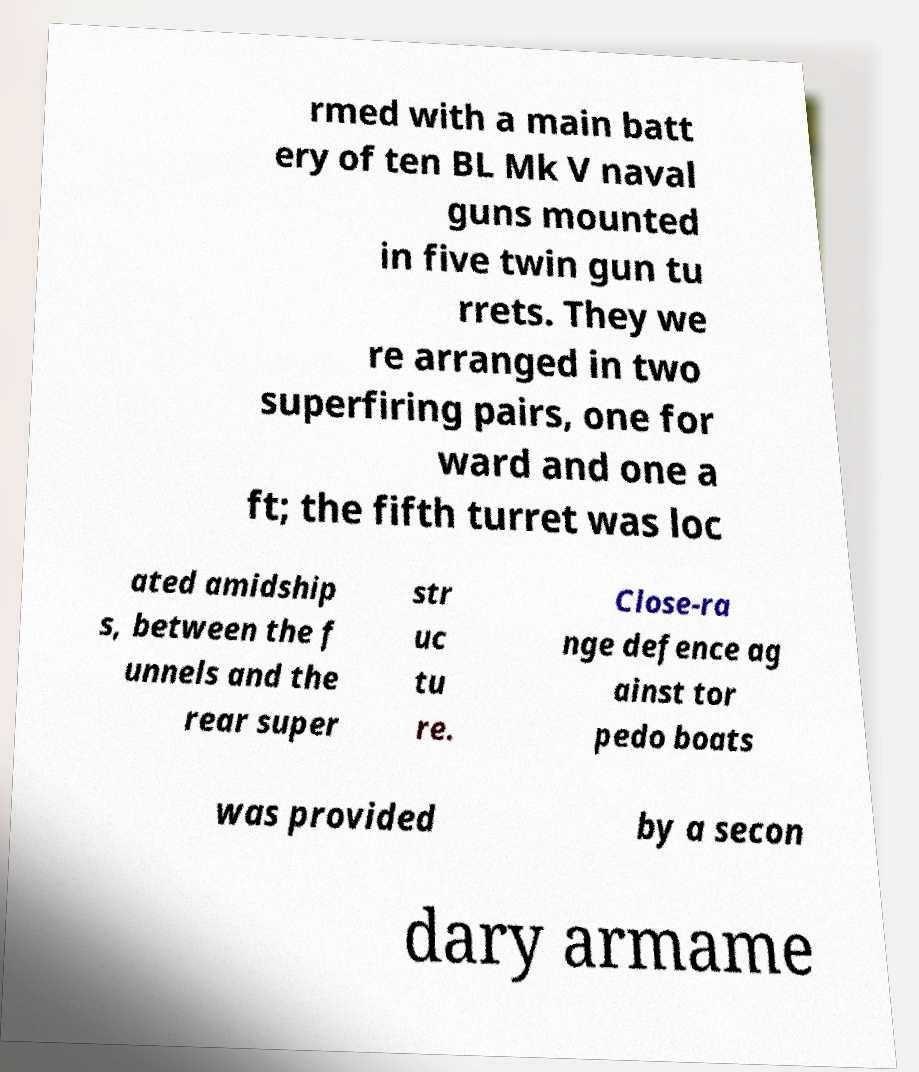Please read and relay the text visible in this image. What does it say? rmed with a main batt ery of ten BL Mk V naval guns mounted in five twin gun tu rrets. They we re arranged in two superfiring pairs, one for ward and one a ft; the fifth turret was loc ated amidship s, between the f unnels and the rear super str uc tu re. Close-ra nge defence ag ainst tor pedo boats was provided by a secon dary armame 